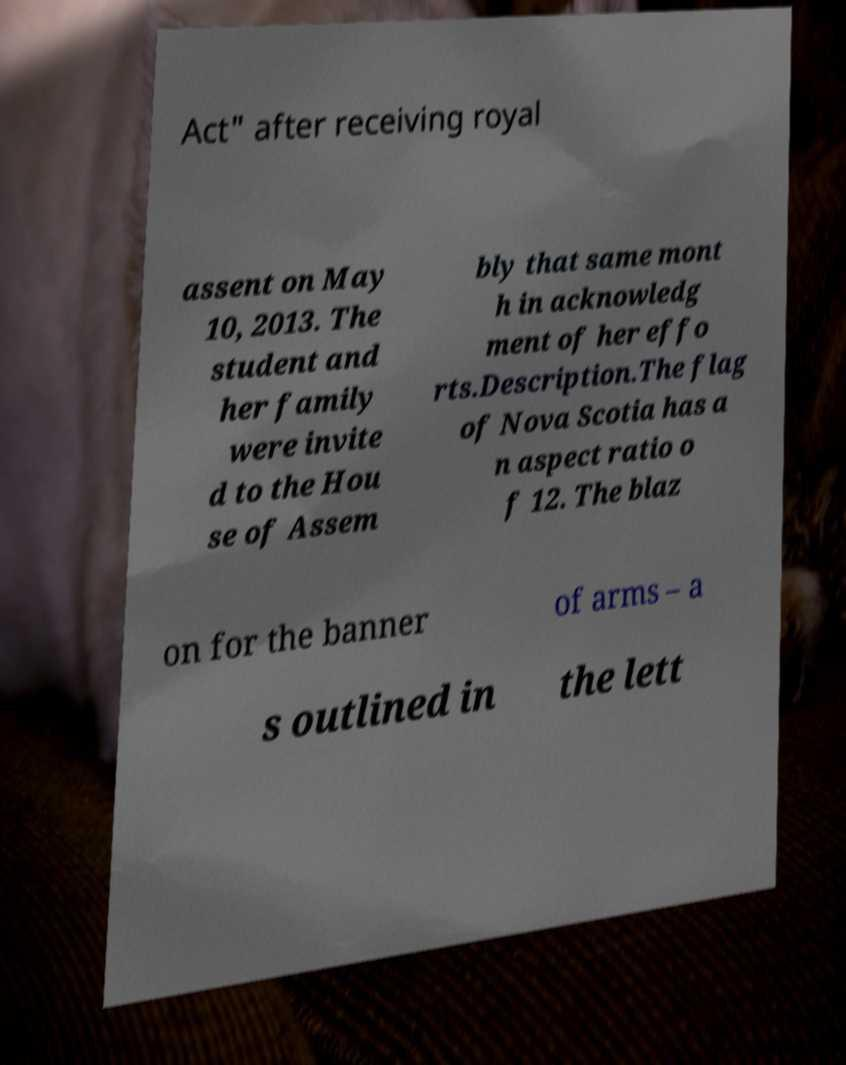There's text embedded in this image that I need extracted. Can you transcribe it verbatim? Act" after receiving royal assent on May 10, 2013. The student and her family were invite d to the Hou se of Assem bly that same mont h in acknowledg ment of her effo rts.Description.The flag of Nova Scotia has a n aspect ratio o f 12. The blaz on for the banner of arms – a s outlined in the lett 